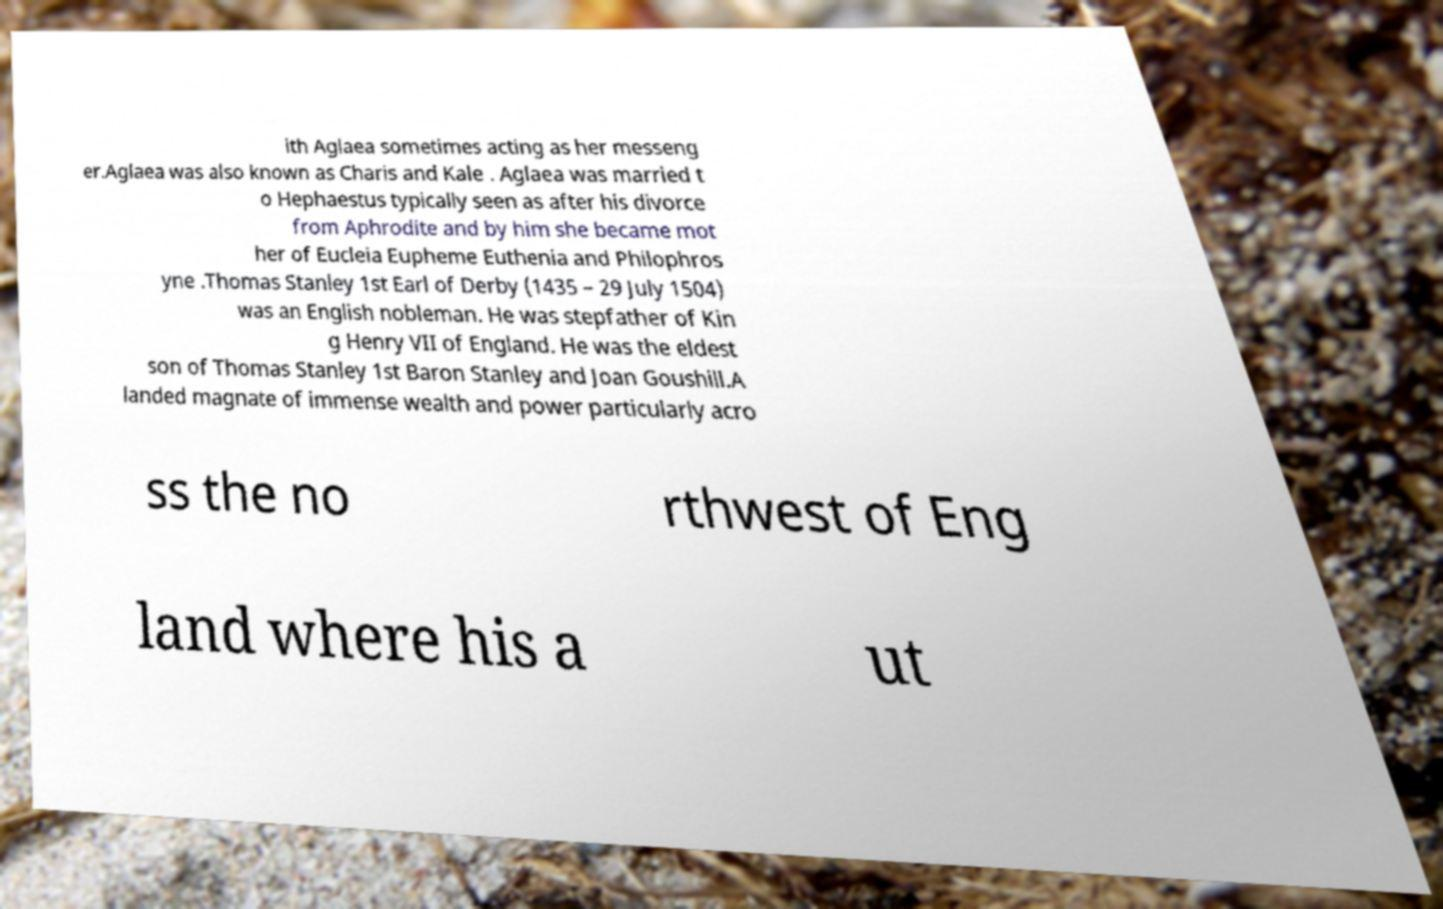Could you extract and type out the text from this image? ith Aglaea sometimes acting as her messeng er.Aglaea was also known as Charis and Kale . Aglaea was married t o Hephaestus typically seen as after his divorce from Aphrodite and by him she became mot her of Eucleia Eupheme Euthenia and Philophros yne .Thomas Stanley 1st Earl of Derby (1435 – 29 July 1504) was an English nobleman. He was stepfather of Kin g Henry VII of England. He was the eldest son of Thomas Stanley 1st Baron Stanley and Joan Goushill.A landed magnate of immense wealth and power particularly acro ss the no rthwest of Eng land where his a ut 